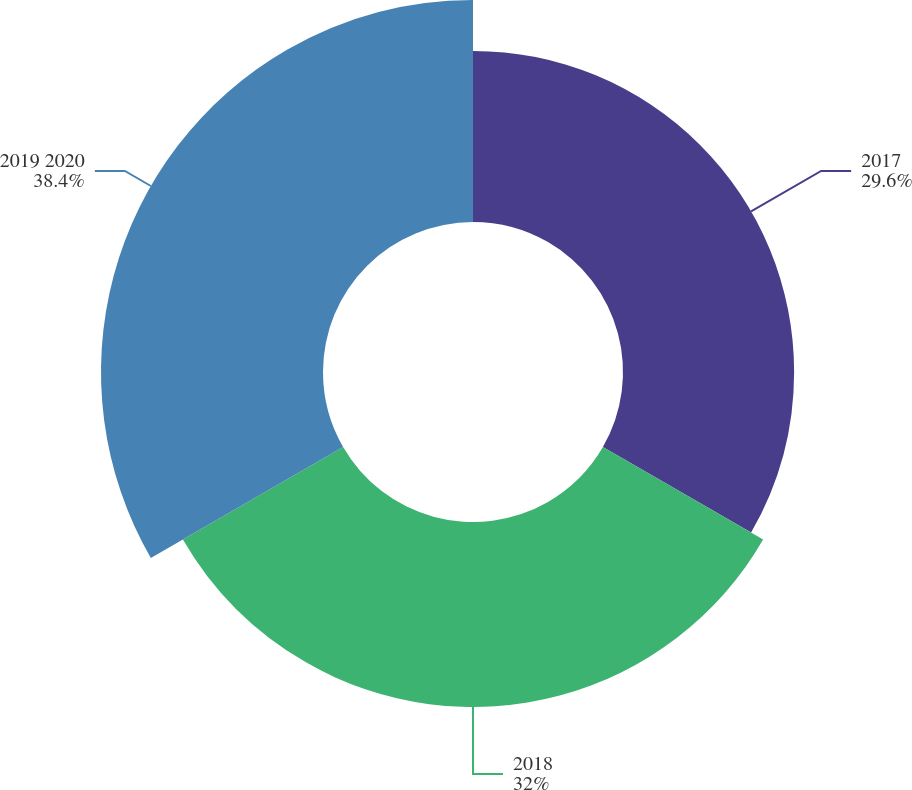Convert chart to OTSL. <chart><loc_0><loc_0><loc_500><loc_500><pie_chart><fcel>2017<fcel>2018<fcel>2019 2020<nl><fcel>29.6%<fcel>32.0%<fcel>38.4%<nl></chart> 